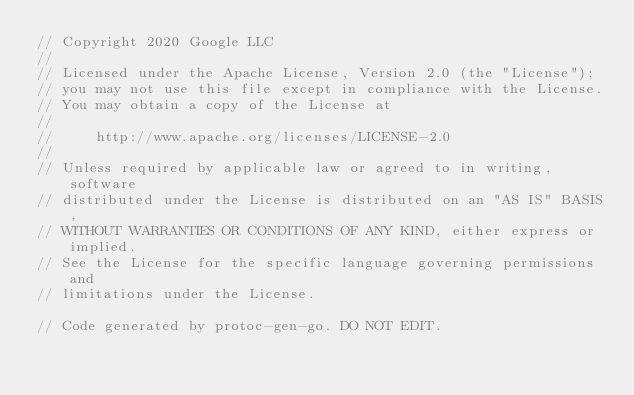Convert code to text. <code><loc_0><loc_0><loc_500><loc_500><_Go_>// Copyright 2020 Google LLC
//
// Licensed under the Apache License, Version 2.0 (the "License");
// you may not use this file except in compliance with the License.
// You may obtain a copy of the License at
//
//     http://www.apache.org/licenses/LICENSE-2.0
//
// Unless required by applicable law or agreed to in writing, software
// distributed under the License is distributed on an "AS IS" BASIS,
// WITHOUT WARRANTIES OR CONDITIONS OF ANY KIND, either express or implied.
// See the License for the specific language governing permissions and
// limitations under the License.

// Code generated by protoc-gen-go. DO NOT EDIT.</code> 